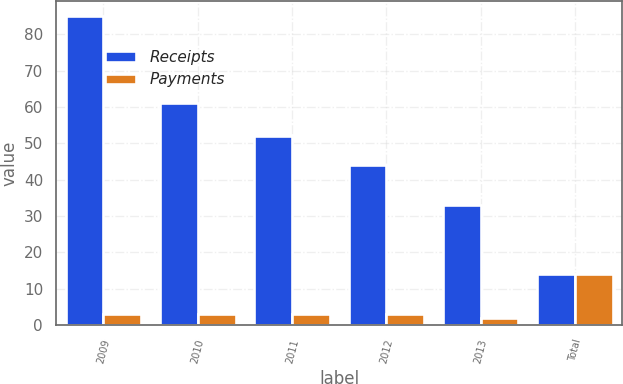Convert chart. <chart><loc_0><loc_0><loc_500><loc_500><stacked_bar_chart><ecel><fcel>2009<fcel>2010<fcel>2011<fcel>2012<fcel>2013<fcel>Total<nl><fcel>Receipts<fcel>85<fcel>61<fcel>52<fcel>44<fcel>33<fcel>14<nl><fcel>Payments<fcel>3<fcel>3<fcel>3<fcel>3<fcel>2<fcel>14<nl></chart> 